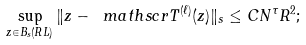Convert formula to latex. <formula><loc_0><loc_0><loc_500><loc_500>\sup _ { z \in B _ { s } ( R L ) } \| z - \ m a t h s c r { T } ^ { ( \ell ) } ( z ) \| _ { s } \leq C N ^ { \tau } R ^ { 2 } ;</formula> 